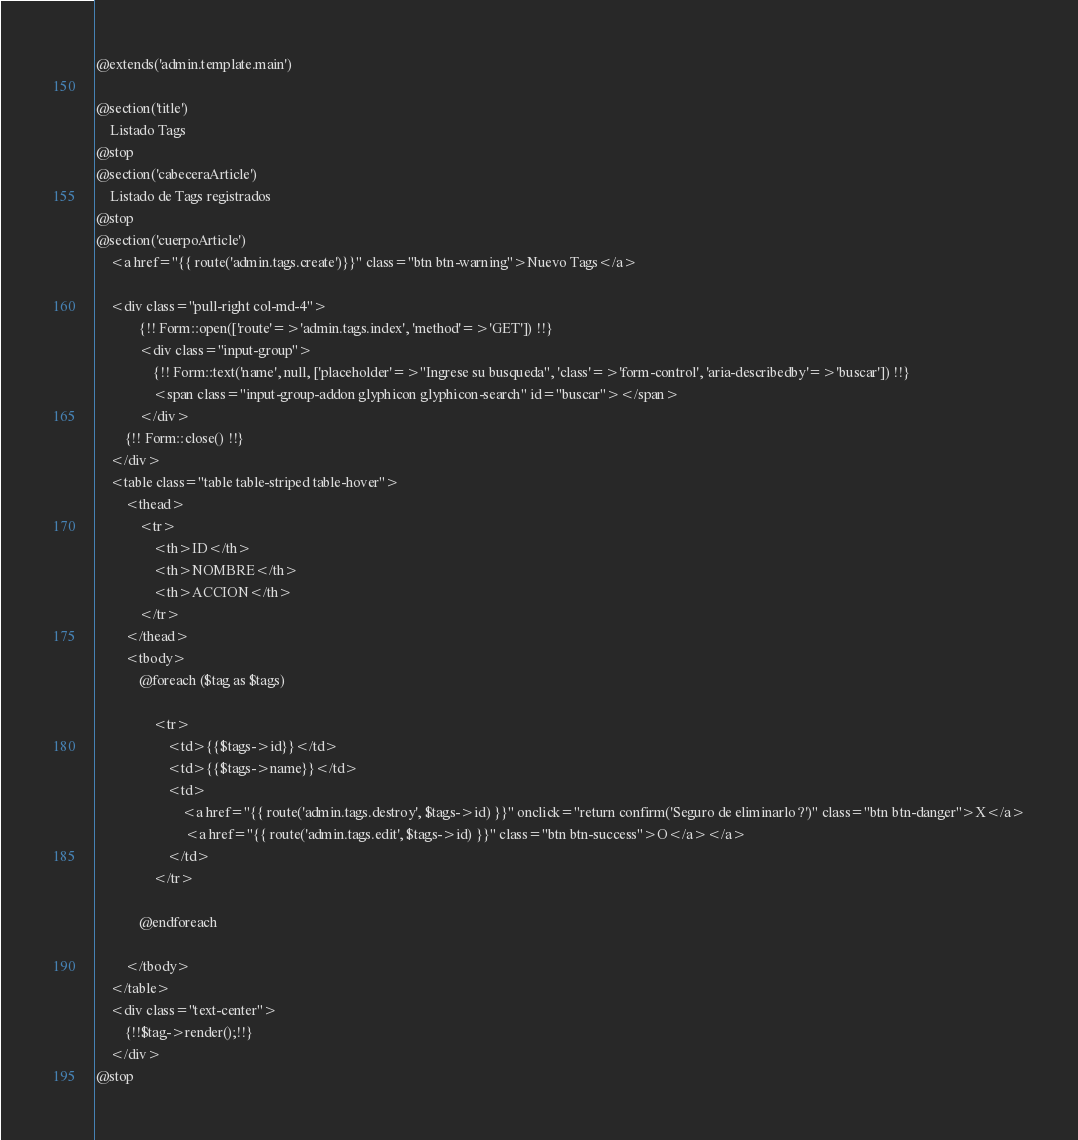Convert code to text. <code><loc_0><loc_0><loc_500><loc_500><_PHP_>@extends('admin.template.main')

@section('title')
	Listado Tags
@stop
@section('cabeceraArticle')
	Listado de Tags registrados
@stop
@section('cuerpoArticle')
	<a href="{{ route('admin.tags.create')}}" class="btn btn-warning">Nuevo Tags</a>
	
	<div class="pull-right col-md-4">
			{!! Form::open(['route'=>'admin.tags.index', 'method'=>'GET']) !!}
			<div class="input-group">
				{!! Form::text('name', null, ['placeholder'=>"Ingrese su busqueda", 'class'=>'form-control', 'aria-describedby'=>'buscar']) !!}
			    <span class="input-group-addon glyphicon glyphicon-search" id="buscar"></span>
			</div>
		{!! Form::close() !!}
	</div>
	<table class="table table-striped table-hover">
		<thead>
			<tr>
				<th>ID</th>
				<th>NOMBRE</th>
				<th>ACCION</th>
			</tr>
		</thead>
		<tbody>
			@foreach ($tag as $tags)

				<tr>
					<td>{{$tags->id}}</td>
					<td>{{$tags->name}}</td>
					<td>
						<a href="{{ route('admin.tags.destroy', $tags->id) }}" onclick="return confirm('Seguro de eliminarlo ?')" class="btn btn-danger">X</a>
						 <a href="{{ route('admin.tags.edit', $tags->id) }}" class="btn btn-success">O</a></a>
					</td>
				</tr>
				
			@endforeach
			
		</tbody>
	</table>
	<div class="text-center">
		{!!$tag->render();!!}
	</div>
@stop
</code> 